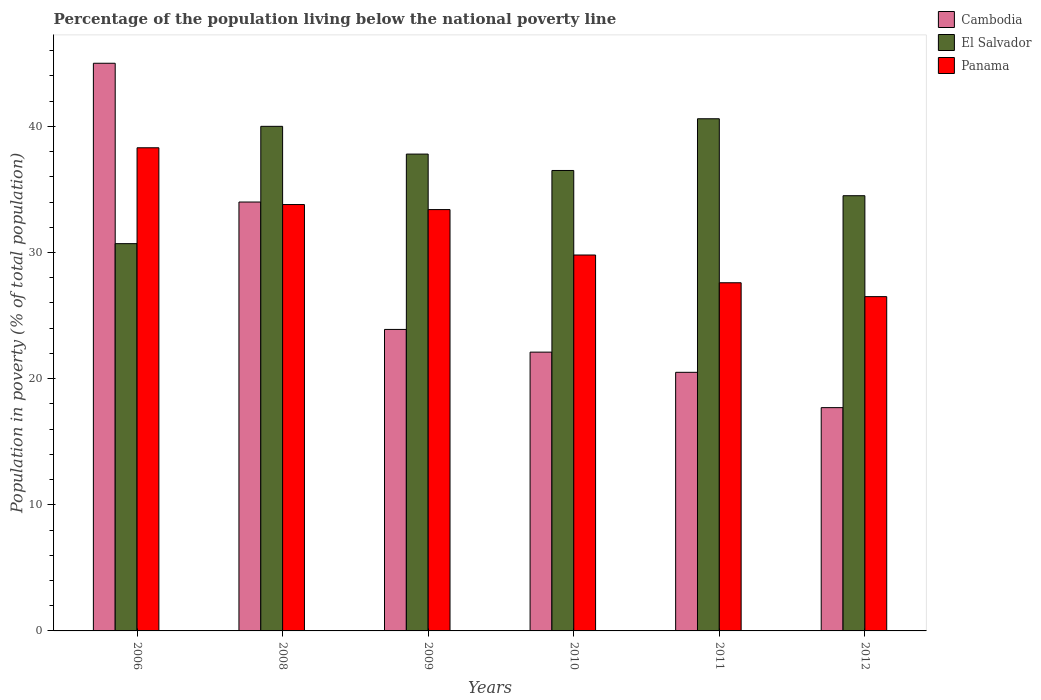How many different coloured bars are there?
Offer a very short reply. 3. How many groups of bars are there?
Make the answer very short. 6. Are the number of bars per tick equal to the number of legend labels?
Your answer should be very brief. Yes. What is the label of the 6th group of bars from the left?
Your response must be concise. 2012. In how many cases, is the number of bars for a given year not equal to the number of legend labels?
Your response must be concise. 0. Across all years, what is the minimum percentage of the population living below the national poverty line in El Salvador?
Provide a short and direct response. 30.7. What is the total percentage of the population living below the national poverty line in El Salvador in the graph?
Your answer should be very brief. 220.1. What is the difference between the percentage of the population living below the national poverty line in Cambodia in 2010 and that in 2012?
Provide a succinct answer. 4.4. What is the difference between the percentage of the population living below the national poverty line in Panama in 2011 and the percentage of the population living below the national poverty line in El Salvador in 2009?
Give a very brief answer. -10.2. What is the average percentage of the population living below the national poverty line in El Salvador per year?
Provide a short and direct response. 36.68. In how many years, is the percentage of the population living below the national poverty line in El Salvador greater than 20 %?
Offer a very short reply. 6. What is the ratio of the percentage of the population living below the national poverty line in El Salvador in 2008 to that in 2011?
Offer a terse response. 0.99. Is the difference between the percentage of the population living below the national poverty line in Cambodia in 2011 and 2012 greater than the difference between the percentage of the population living below the national poverty line in El Salvador in 2011 and 2012?
Make the answer very short. No. What is the difference between the highest and the second highest percentage of the population living below the national poverty line in Panama?
Keep it short and to the point. 4.5. What is the difference between the highest and the lowest percentage of the population living below the national poverty line in Cambodia?
Your answer should be very brief. 27.3. Is the sum of the percentage of the population living below the national poverty line in Cambodia in 2006 and 2011 greater than the maximum percentage of the population living below the national poverty line in Panama across all years?
Ensure brevity in your answer.  Yes. What does the 2nd bar from the left in 2006 represents?
Ensure brevity in your answer.  El Salvador. What does the 3rd bar from the right in 2011 represents?
Provide a succinct answer. Cambodia. Is it the case that in every year, the sum of the percentage of the population living below the national poverty line in El Salvador and percentage of the population living below the national poverty line in Cambodia is greater than the percentage of the population living below the national poverty line in Panama?
Your answer should be compact. Yes. How many bars are there?
Offer a very short reply. 18. Are all the bars in the graph horizontal?
Provide a succinct answer. No. How many years are there in the graph?
Offer a very short reply. 6. Where does the legend appear in the graph?
Your answer should be very brief. Top right. How many legend labels are there?
Provide a short and direct response. 3. What is the title of the graph?
Your answer should be compact. Percentage of the population living below the national poverty line. What is the label or title of the X-axis?
Your answer should be very brief. Years. What is the label or title of the Y-axis?
Your answer should be compact. Population in poverty (% of total population). What is the Population in poverty (% of total population) of El Salvador in 2006?
Your response must be concise. 30.7. What is the Population in poverty (% of total population) of Panama in 2006?
Ensure brevity in your answer.  38.3. What is the Population in poverty (% of total population) in Cambodia in 2008?
Your answer should be compact. 34. What is the Population in poverty (% of total population) of Panama in 2008?
Your answer should be very brief. 33.8. What is the Population in poverty (% of total population) of Cambodia in 2009?
Give a very brief answer. 23.9. What is the Population in poverty (% of total population) in El Salvador in 2009?
Offer a very short reply. 37.8. What is the Population in poverty (% of total population) in Panama in 2009?
Your response must be concise. 33.4. What is the Population in poverty (% of total population) in Cambodia in 2010?
Provide a succinct answer. 22.1. What is the Population in poverty (% of total population) in El Salvador in 2010?
Ensure brevity in your answer.  36.5. What is the Population in poverty (% of total population) of Panama in 2010?
Offer a very short reply. 29.8. What is the Population in poverty (% of total population) in Cambodia in 2011?
Offer a terse response. 20.5. What is the Population in poverty (% of total population) of El Salvador in 2011?
Ensure brevity in your answer.  40.6. What is the Population in poverty (% of total population) of Panama in 2011?
Your response must be concise. 27.6. What is the Population in poverty (% of total population) in Cambodia in 2012?
Your answer should be compact. 17.7. What is the Population in poverty (% of total population) in El Salvador in 2012?
Give a very brief answer. 34.5. What is the Population in poverty (% of total population) in Panama in 2012?
Ensure brevity in your answer.  26.5. Across all years, what is the maximum Population in poverty (% of total population) in El Salvador?
Give a very brief answer. 40.6. Across all years, what is the maximum Population in poverty (% of total population) of Panama?
Keep it short and to the point. 38.3. Across all years, what is the minimum Population in poverty (% of total population) of Cambodia?
Ensure brevity in your answer.  17.7. Across all years, what is the minimum Population in poverty (% of total population) of El Salvador?
Your answer should be very brief. 30.7. What is the total Population in poverty (% of total population) in Cambodia in the graph?
Make the answer very short. 163.2. What is the total Population in poverty (% of total population) in El Salvador in the graph?
Provide a succinct answer. 220.1. What is the total Population in poverty (% of total population) of Panama in the graph?
Your answer should be very brief. 189.4. What is the difference between the Population in poverty (% of total population) of Panama in 2006 and that in 2008?
Ensure brevity in your answer.  4.5. What is the difference between the Population in poverty (% of total population) of Cambodia in 2006 and that in 2009?
Offer a very short reply. 21.1. What is the difference between the Population in poverty (% of total population) in El Salvador in 2006 and that in 2009?
Keep it short and to the point. -7.1. What is the difference between the Population in poverty (% of total population) of Panama in 2006 and that in 2009?
Offer a very short reply. 4.9. What is the difference between the Population in poverty (% of total population) of Cambodia in 2006 and that in 2010?
Provide a short and direct response. 22.9. What is the difference between the Population in poverty (% of total population) of Panama in 2006 and that in 2010?
Your answer should be compact. 8.5. What is the difference between the Population in poverty (% of total population) of El Salvador in 2006 and that in 2011?
Provide a succinct answer. -9.9. What is the difference between the Population in poverty (% of total population) in Cambodia in 2006 and that in 2012?
Offer a very short reply. 27.3. What is the difference between the Population in poverty (% of total population) of Panama in 2008 and that in 2009?
Offer a terse response. 0.4. What is the difference between the Population in poverty (% of total population) of Panama in 2008 and that in 2010?
Ensure brevity in your answer.  4. What is the difference between the Population in poverty (% of total population) in Cambodia in 2008 and that in 2011?
Your answer should be very brief. 13.5. What is the difference between the Population in poverty (% of total population) in El Salvador in 2008 and that in 2011?
Offer a terse response. -0.6. What is the difference between the Population in poverty (% of total population) of Panama in 2008 and that in 2011?
Give a very brief answer. 6.2. What is the difference between the Population in poverty (% of total population) of Cambodia in 2008 and that in 2012?
Provide a short and direct response. 16.3. What is the difference between the Population in poverty (% of total population) in Cambodia in 2009 and that in 2010?
Give a very brief answer. 1.8. What is the difference between the Population in poverty (% of total population) of Cambodia in 2009 and that in 2011?
Keep it short and to the point. 3.4. What is the difference between the Population in poverty (% of total population) in Panama in 2009 and that in 2011?
Your answer should be compact. 5.8. What is the difference between the Population in poverty (% of total population) in Cambodia in 2009 and that in 2012?
Make the answer very short. 6.2. What is the difference between the Population in poverty (% of total population) in El Salvador in 2009 and that in 2012?
Give a very brief answer. 3.3. What is the difference between the Population in poverty (% of total population) in El Salvador in 2010 and that in 2011?
Ensure brevity in your answer.  -4.1. What is the difference between the Population in poverty (% of total population) in Cambodia in 2010 and that in 2012?
Your response must be concise. 4.4. What is the difference between the Population in poverty (% of total population) in Panama in 2010 and that in 2012?
Provide a short and direct response. 3.3. What is the difference between the Population in poverty (% of total population) in El Salvador in 2011 and that in 2012?
Your answer should be very brief. 6.1. What is the difference between the Population in poverty (% of total population) of Cambodia in 2006 and the Population in poverty (% of total population) of El Salvador in 2008?
Your answer should be very brief. 5. What is the difference between the Population in poverty (% of total population) of Cambodia in 2006 and the Population in poverty (% of total population) of Panama in 2008?
Provide a succinct answer. 11.2. What is the difference between the Population in poverty (% of total population) of El Salvador in 2006 and the Population in poverty (% of total population) of Panama in 2008?
Ensure brevity in your answer.  -3.1. What is the difference between the Population in poverty (% of total population) of Cambodia in 2006 and the Population in poverty (% of total population) of El Salvador in 2009?
Offer a very short reply. 7.2. What is the difference between the Population in poverty (% of total population) of Cambodia in 2006 and the Population in poverty (% of total population) of El Salvador in 2010?
Make the answer very short. 8.5. What is the difference between the Population in poverty (% of total population) in El Salvador in 2006 and the Population in poverty (% of total population) in Panama in 2010?
Your answer should be compact. 0.9. What is the difference between the Population in poverty (% of total population) of Cambodia in 2006 and the Population in poverty (% of total population) of El Salvador in 2011?
Offer a terse response. 4.4. What is the difference between the Population in poverty (% of total population) of El Salvador in 2006 and the Population in poverty (% of total population) of Panama in 2011?
Your answer should be very brief. 3.1. What is the difference between the Population in poverty (% of total population) in El Salvador in 2006 and the Population in poverty (% of total population) in Panama in 2012?
Offer a terse response. 4.2. What is the difference between the Population in poverty (% of total population) of El Salvador in 2008 and the Population in poverty (% of total population) of Panama in 2009?
Ensure brevity in your answer.  6.6. What is the difference between the Population in poverty (% of total population) of Cambodia in 2008 and the Population in poverty (% of total population) of El Salvador in 2010?
Keep it short and to the point. -2.5. What is the difference between the Population in poverty (% of total population) in El Salvador in 2008 and the Population in poverty (% of total population) in Panama in 2010?
Make the answer very short. 10.2. What is the difference between the Population in poverty (% of total population) of El Salvador in 2008 and the Population in poverty (% of total population) of Panama in 2011?
Offer a very short reply. 12.4. What is the difference between the Population in poverty (% of total population) of Cambodia in 2008 and the Population in poverty (% of total population) of El Salvador in 2012?
Offer a terse response. -0.5. What is the difference between the Population in poverty (% of total population) of Cambodia in 2009 and the Population in poverty (% of total population) of El Salvador in 2010?
Provide a short and direct response. -12.6. What is the difference between the Population in poverty (% of total population) of Cambodia in 2009 and the Population in poverty (% of total population) of El Salvador in 2011?
Your answer should be very brief. -16.7. What is the difference between the Population in poverty (% of total population) in Cambodia in 2009 and the Population in poverty (% of total population) in Panama in 2011?
Keep it short and to the point. -3.7. What is the difference between the Population in poverty (% of total population) in Cambodia in 2009 and the Population in poverty (% of total population) in El Salvador in 2012?
Keep it short and to the point. -10.6. What is the difference between the Population in poverty (% of total population) in El Salvador in 2009 and the Population in poverty (% of total population) in Panama in 2012?
Your answer should be very brief. 11.3. What is the difference between the Population in poverty (% of total population) of Cambodia in 2010 and the Population in poverty (% of total population) of El Salvador in 2011?
Your response must be concise. -18.5. What is the difference between the Population in poverty (% of total population) in Cambodia in 2010 and the Population in poverty (% of total population) in Panama in 2011?
Make the answer very short. -5.5. What is the difference between the Population in poverty (% of total population) of Cambodia in 2010 and the Population in poverty (% of total population) of El Salvador in 2012?
Offer a terse response. -12.4. What is the difference between the Population in poverty (% of total population) in El Salvador in 2010 and the Population in poverty (% of total population) in Panama in 2012?
Your answer should be compact. 10. What is the difference between the Population in poverty (% of total population) of Cambodia in 2011 and the Population in poverty (% of total population) of Panama in 2012?
Provide a succinct answer. -6. What is the average Population in poverty (% of total population) of Cambodia per year?
Provide a short and direct response. 27.2. What is the average Population in poverty (% of total population) of El Salvador per year?
Ensure brevity in your answer.  36.68. What is the average Population in poverty (% of total population) in Panama per year?
Provide a short and direct response. 31.57. In the year 2006, what is the difference between the Population in poverty (% of total population) of El Salvador and Population in poverty (% of total population) of Panama?
Your answer should be compact. -7.6. In the year 2009, what is the difference between the Population in poverty (% of total population) of Cambodia and Population in poverty (% of total population) of El Salvador?
Provide a short and direct response. -13.9. In the year 2009, what is the difference between the Population in poverty (% of total population) in El Salvador and Population in poverty (% of total population) in Panama?
Provide a short and direct response. 4.4. In the year 2010, what is the difference between the Population in poverty (% of total population) in Cambodia and Population in poverty (% of total population) in El Salvador?
Offer a very short reply. -14.4. In the year 2010, what is the difference between the Population in poverty (% of total population) of Cambodia and Population in poverty (% of total population) of Panama?
Offer a terse response. -7.7. In the year 2010, what is the difference between the Population in poverty (% of total population) in El Salvador and Population in poverty (% of total population) in Panama?
Give a very brief answer. 6.7. In the year 2011, what is the difference between the Population in poverty (% of total population) of Cambodia and Population in poverty (% of total population) of El Salvador?
Make the answer very short. -20.1. In the year 2012, what is the difference between the Population in poverty (% of total population) of Cambodia and Population in poverty (% of total population) of El Salvador?
Make the answer very short. -16.8. In the year 2012, what is the difference between the Population in poverty (% of total population) in El Salvador and Population in poverty (% of total population) in Panama?
Your response must be concise. 8. What is the ratio of the Population in poverty (% of total population) of Cambodia in 2006 to that in 2008?
Give a very brief answer. 1.32. What is the ratio of the Population in poverty (% of total population) in El Salvador in 2006 to that in 2008?
Provide a succinct answer. 0.77. What is the ratio of the Population in poverty (% of total population) of Panama in 2006 to that in 2008?
Your answer should be compact. 1.13. What is the ratio of the Population in poverty (% of total population) in Cambodia in 2006 to that in 2009?
Your response must be concise. 1.88. What is the ratio of the Population in poverty (% of total population) in El Salvador in 2006 to that in 2009?
Your response must be concise. 0.81. What is the ratio of the Population in poverty (% of total population) in Panama in 2006 to that in 2009?
Offer a terse response. 1.15. What is the ratio of the Population in poverty (% of total population) in Cambodia in 2006 to that in 2010?
Give a very brief answer. 2.04. What is the ratio of the Population in poverty (% of total population) of El Salvador in 2006 to that in 2010?
Provide a short and direct response. 0.84. What is the ratio of the Population in poverty (% of total population) in Panama in 2006 to that in 2010?
Offer a very short reply. 1.29. What is the ratio of the Population in poverty (% of total population) in Cambodia in 2006 to that in 2011?
Provide a short and direct response. 2.2. What is the ratio of the Population in poverty (% of total population) of El Salvador in 2006 to that in 2011?
Keep it short and to the point. 0.76. What is the ratio of the Population in poverty (% of total population) of Panama in 2006 to that in 2011?
Make the answer very short. 1.39. What is the ratio of the Population in poverty (% of total population) in Cambodia in 2006 to that in 2012?
Make the answer very short. 2.54. What is the ratio of the Population in poverty (% of total population) in El Salvador in 2006 to that in 2012?
Provide a succinct answer. 0.89. What is the ratio of the Population in poverty (% of total population) in Panama in 2006 to that in 2012?
Provide a short and direct response. 1.45. What is the ratio of the Population in poverty (% of total population) of Cambodia in 2008 to that in 2009?
Provide a succinct answer. 1.42. What is the ratio of the Population in poverty (% of total population) in El Salvador in 2008 to that in 2009?
Make the answer very short. 1.06. What is the ratio of the Population in poverty (% of total population) in Panama in 2008 to that in 2009?
Your response must be concise. 1.01. What is the ratio of the Population in poverty (% of total population) in Cambodia in 2008 to that in 2010?
Provide a succinct answer. 1.54. What is the ratio of the Population in poverty (% of total population) of El Salvador in 2008 to that in 2010?
Make the answer very short. 1.1. What is the ratio of the Population in poverty (% of total population) in Panama in 2008 to that in 2010?
Your answer should be very brief. 1.13. What is the ratio of the Population in poverty (% of total population) in Cambodia in 2008 to that in 2011?
Your response must be concise. 1.66. What is the ratio of the Population in poverty (% of total population) of El Salvador in 2008 to that in 2011?
Provide a short and direct response. 0.99. What is the ratio of the Population in poverty (% of total population) in Panama in 2008 to that in 2011?
Your answer should be very brief. 1.22. What is the ratio of the Population in poverty (% of total population) of Cambodia in 2008 to that in 2012?
Ensure brevity in your answer.  1.92. What is the ratio of the Population in poverty (% of total population) of El Salvador in 2008 to that in 2012?
Your answer should be very brief. 1.16. What is the ratio of the Population in poverty (% of total population) of Panama in 2008 to that in 2012?
Give a very brief answer. 1.28. What is the ratio of the Population in poverty (% of total population) of Cambodia in 2009 to that in 2010?
Keep it short and to the point. 1.08. What is the ratio of the Population in poverty (% of total population) of El Salvador in 2009 to that in 2010?
Your answer should be very brief. 1.04. What is the ratio of the Population in poverty (% of total population) in Panama in 2009 to that in 2010?
Keep it short and to the point. 1.12. What is the ratio of the Population in poverty (% of total population) of Cambodia in 2009 to that in 2011?
Your answer should be very brief. 1.17. What is the ratio of the Population in poverty (% of total population) of El Salvador in 2009 to that in 2011?
Provide a succinct answer. 0.93. What is the ratio of the Population in poverty (% of total population) in Panama in 2009 to that in 2011?
Provide a succinct answer. 1.21. What is the ratio of the Population in poverty (% of total population) in Cambodia in 2009 to that in 2012?
Ensure brevity in your answer.  1.35. What is the ratio of the Population in poverty (% of total population) in El Salvador in 2009 to that in 2012?
Offer a terse response. 1.1. What is the ratio of the Population in poverty (% of total population) of Panama in 2009 to that in 2012?
Offer a very short reply. 1.26. What is the ratio of the Population in poverty (% of total population) of Cambodia in 2010 to that in 2011?
Provide a short and direct response. 1.08. What is the ratio of the Population in poverty (% of total population) in El Salvador in 2010 to that in 2011?
Keep it short and to the point. 0.9. What is the ratio of the Population in poverty (% of total population) of Panama in 2010 to that in 2011?
Provide a short and direct response. 1.08. What is the ratio of the Population in poverty (% of total population) of Cambodia in 2010 to that in 2012?
Your response must be concise. 1.25. What is the ratio of the Population in poverty (% of total population) in El Salvador in 2010 to that in 2012?
Provide a short and direct response. 1.06. What is the ratio of the Population in poverty (% of total population) in Panama in 2010 to that in 2012?
Your response must be concise. 1.12. What is the ratio of the Population in poverty (% of total population) in Cambodia in 2011 to that in 2012?
Your answer should be compact. 1.16. What is the ratio of the Population in poverty (% of total population) of El Salvador in 2011 to that in 2012?
Provide a short and direct response. 1.18. What is the ratio of the Population in poverty (% of total population) of Panama in 2011 to that in 2012?
Your answer should be very brief. 1.04. What is the difference between the highest and the second highest Population in poverty (% of total population) of Cambodia?
Your response must be concise. 11. What is the difference between the highest and the second highest Population in poverty (% of total population) of El Salvador?
Keep it short and to the point. 0.6. What is the difference between the highest and the second highest Population in poverty (% of total population) in Panama?
Provide a short and direct response. 4.5. What is the difference between the highest and the lowest Population in poverty (% of total population) of Cambodia?
Keep it short and to the point. 27.3. What is the difference between the highest and the lowest Population in poverty (% of total population) of Panama?
Offer a very short reply. 11.8. 